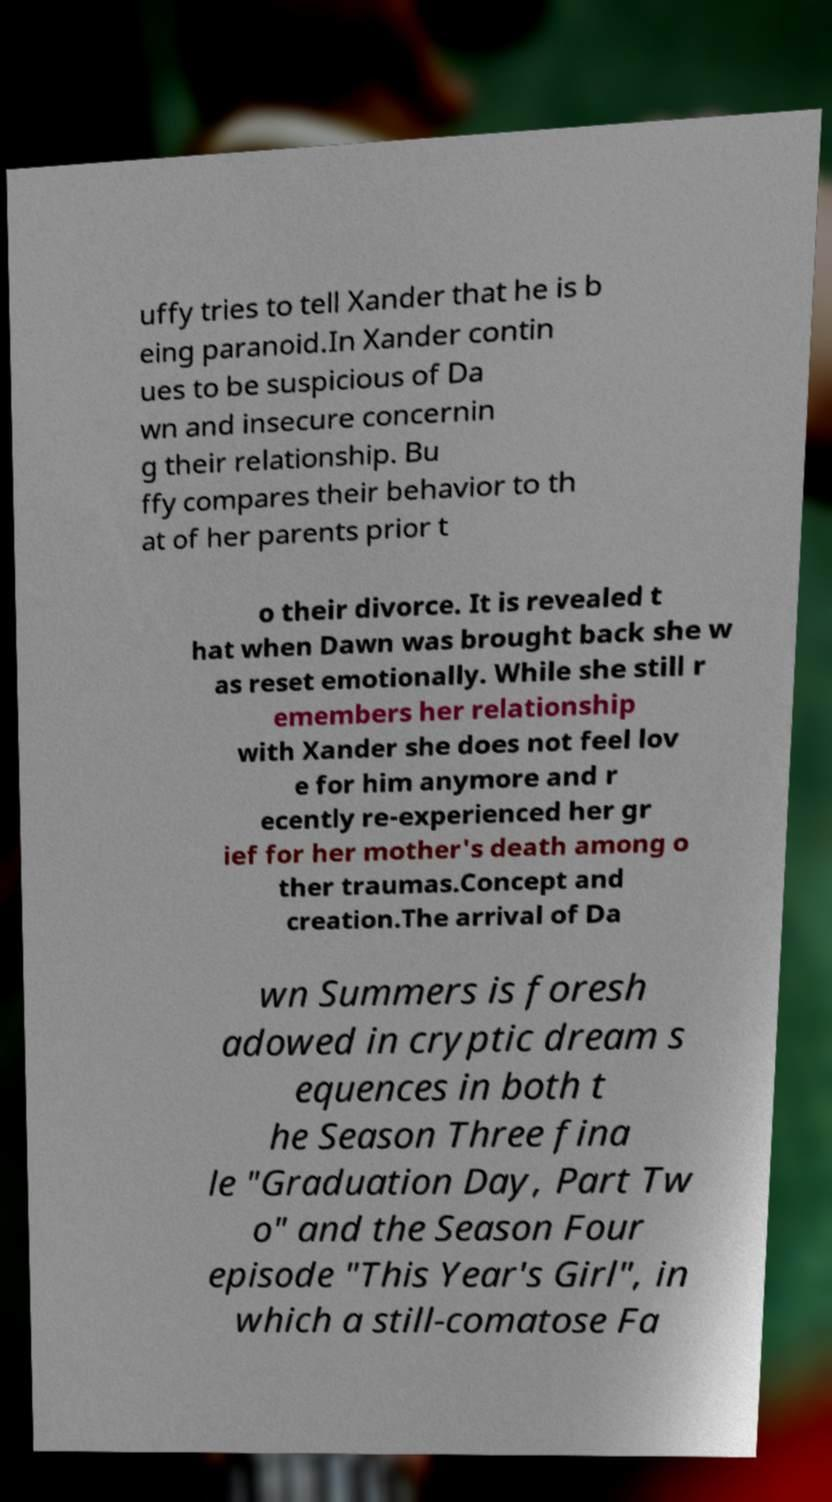For documentation purposes, I need the text within this image transcribed. Could you provide that? uffy tries to tell Xander that he is b eing paranoid.In Xander contin ues to be suspicious of Da wn and insecure concernin g their relationship. Bu ffy compares their behavior to th at of her parents prior t o their divorce. It is revealed t hat when Dawn was brought back she w as reset emotionally. While she still r emembers her relationship with Xander she does not feel lov e for him anymore and r ecently re-experienced her gr ief for her mother's death among o ther traumas.Concept and creation.The arrival of Da wn Summers is foresh adowed in cryptic dream s equences in both t he Season Three fina le "Graduation Day, Part Tw o" and the Season Four episode "This Year's Girl", in which a still-comatose Fa 